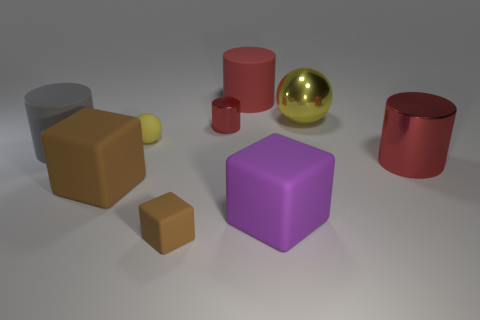What shape is the big matte thing that is the same color as the large shiny cylinder?
Ensure brevity in your answer.  Cylinder. Do the yellow rubber object and the sphere that is right of the large purple rubber object have the same size?
Provide a succinct answer. No. Are there fewer big purple objects on the left side of the tiny yellow rubber ball than tiny red things?
Your answer should be compact. Yes. What material is the other big red thing that is the same shape as the red rubber thing?
Provide a short and direct response. Metal. What shape is the object that is on the left side of the tiny red metal thing and behind the big gray cylinder?
Your answer should be compact. Sphere. The other red object that is made of the same material as the tiny red object is what shape?
Your answer should be very brief. Cylinder. There is a cylinder that is in front of the gray cylinder; what material is it?
Offer a very short reply. Metal. Is the size of the yellow thing that is to the left of the purple rubber block the same as the matte cylinder that is on the left side of the large brown block?
Provide a short and direct response. No. What is the color of the large metal sphere?
Provide a succinct answer. Yellow. There is a big yellow thing that is right of the gray cylinder; is its shape the same as the small yellow rubber thing?
Ensure brevity in your answer.  Yes. 